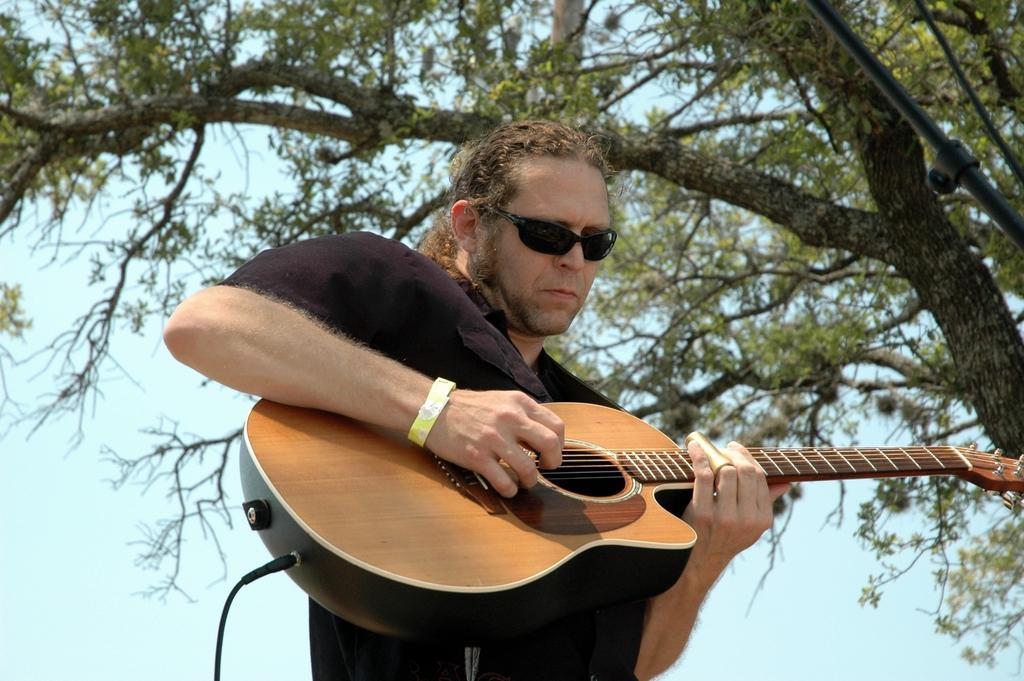How would you summarize this image in a sentence or two? in the picture there was the man playing guitar ,beside the man there was the tree we can also a micro phone stand near the person,we can also see the clear sky. 